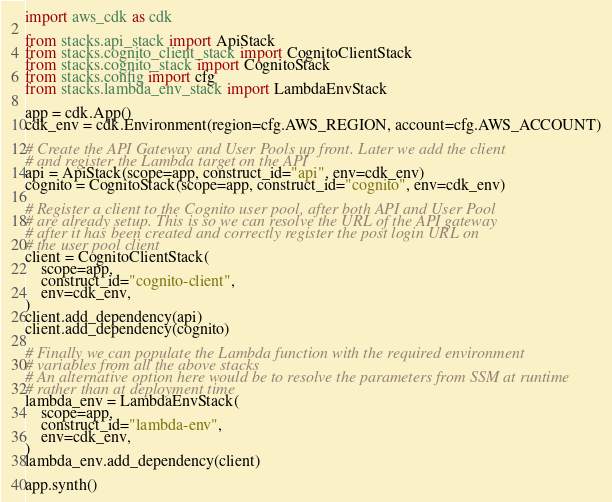Convert code to text. <code><loc_0><loc_0><loc_500><loc_500><_Python_>import aws_cdk as cdk

from stacks.api_stack import ApiStack
from stacks.cognito_client_stack import CognitoClientStack
from stacks.cognito_stack import CognitoStack
from stacks.config import cfg
from stacks.lambda_env_stack import LambdaEnvStack

app = cdk.App()
cdk_env = cdk.Environment(region=cfg.AWS_REGION, account=cfg.AWS_ACCOUNT)

# Create the API Gateway and User Pools up front. Later we add the client
# and register the Lambda target on the API
api = ApiStack(scope=app, construct_id="api", env=cdk_env)
cognito = CognitoStack(scope=app, construct_id="cognito", env=cdk_env)

# Register a client to the Cognito user pool, after both API and User Pool
# are already setup. This is so we can resolve the URL of the API gateway
# after it has been created and correctly register the post login URL on
# the user pool client
client = CognitoClientStack(
    scope=app,
    construct_id="cognito-client",
    env=cdk_env,
)
client.add_dependency(api)
client.add_dependency(cognito)

# Finally we can populate the Lambda function with the required environment
# variables from all the above stacks
# An alternative option here would be to resolve the parameters from SSM at runtime
# rather than at deployment time
lambda_env = LambdaEnvStack(
    scope=app,
    construct_id="lambda-env",
    env=cdk_env,
)
lambda_env.add_dependency(client)

app.synth()
</code> 